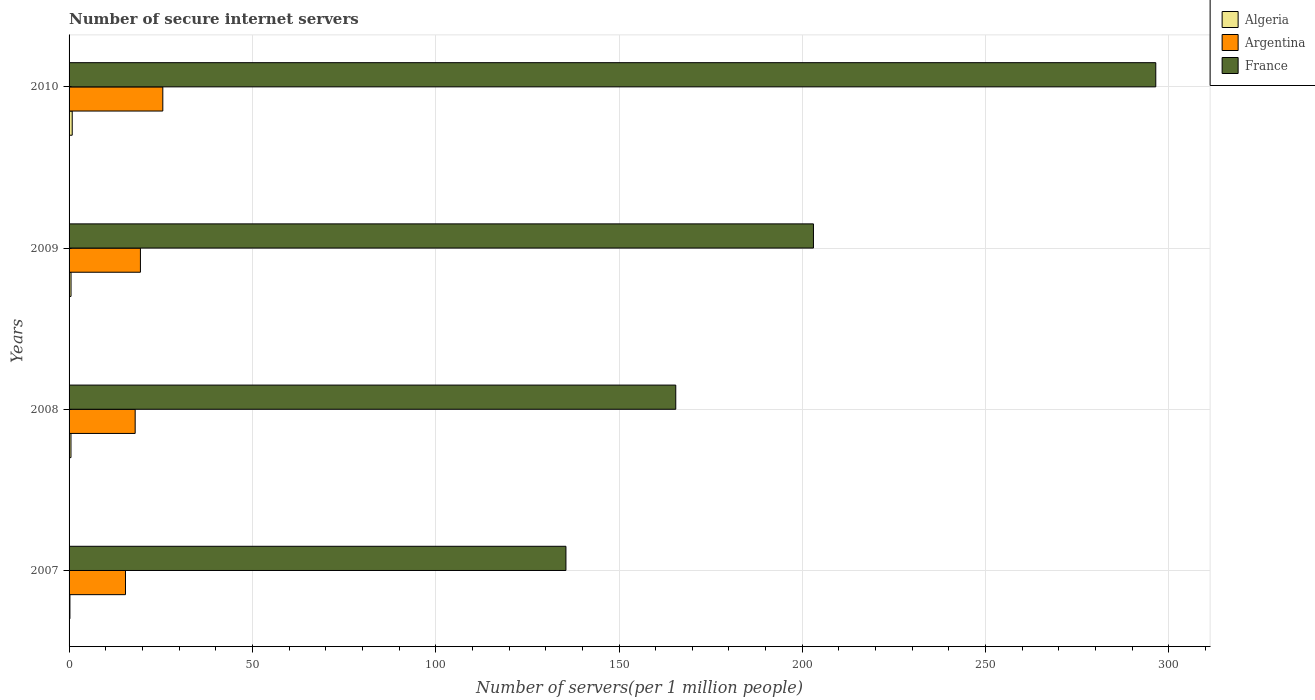How many different coloured bars are there?
Your answer should be compact. 3. How many groups of bars are there?
Ensure brevity in your answer.  4. Are the number of bars per tick equal to the number of legend labels?
Ensure brevity in your answer.  Yes. How many bars are there on the 4th tick from the top?
Make the answer very short. 3. How many bars are there on the 3rd tick from the bottom?
Make the answer very short. 3. What is the number of secure internet servers in Algeria in 2010?
Ensure brevity in your answer.  0.86. Across all years, what is the maximum number of secure internet servers in Algeria?
Give a very brief answer. 0.86. Across all years, what is the minimum number of secure internet servers in France?
Make the answer very short. 135.53. In which year was the number of secure internet servers in Argentina maximum?
Your answer should be compact. 2010. In which year was the number of secure internet servers in Algeria minimum?
Provide a succinct answer. 2007. What is the total number of secure internet servers in Algeria in the graph?
Provide a short and direct response. 2.15. What is the difference between the number of secure internet servers in Algeria in 2007 and that in 2009?
Provide a short and direct response. -0.3. What is the difference between the number of secure internet servers in Argentina in 2010 and the number of secure internet servers in Algeria in 2007?
Provide a succinct answer. 25.33. What is the average number of secure internet servers in Algeria per year?
Your response must be concise. 0.54. In the year 2009, what is the difference between the number of secure internet servers in Argentina and number of secure internet servers in France?
Ensure brevity in your answer.  -183.58. In how many years, is the number of secure internet servers in France greater than 30 ?
Make the answer very short. 4. What is the ratio of the number of secure internet servers in Argentina in 2007 to that in 2008?
Ensure brevity in your answer.  0.85. Is the number of secure internet servers in Algeria in 2008 less than that in 2009?
Make the answer very short. Yes. What is the difference between the highest and the second highest number of secure internet servers in Algeria?
Provide a short and direct response. 0.32. What is the difference between the highest and the lowest number of secure internet servers in Argentina?
Offer a very short reply. 10.18. What does the 1st bar from the bottom in 2008 represents?
Offer a terse response. Algeria. Is it the case that in every year, the sum of the number of secure internet servers in Algeria and number of secure internet servers in France is greater than the number of secure internet servers in Argentina?
Your answer should be very brief. Yes. How many years are there in the graph?
Your answer should be very brief. 4. What is the difference between two consecutive major ticks on the X-axis?
Give a very brief answer. 50. Does the graph contain any zero values?
Ensure brevity in your answer.  No. Does the graph contain grids?
Your response must be concise. Yes. Where does the legend appear in the graph?
Provide a short and direct response. Top right. How many legend labels are there?
Provide a succinct answer. 3. What is the title of the graph?
Your answer should be compact. Number of secure internet servers. What is the label or title of the X-axis?
Give a very brief answer. Number of servers(per 1 million people). What is the label or title of the Y-axis?
Offer a very short reply. Years. What is the Number of servers(per 1 million people) of Algeria in 2007?
Provide a short and direct response. 0.23. What is the Number of servers(per 1 million people) of Argentina in 2007?
Offer a terse response. 15.39. What is the Number of servers(per 1 million people) of France in 2007?
Provide a succinct answer. 135.53. What is the Number of servers(per 1 million people) in Algeria in 2008?
Offer a terse response. 0.52. What is the Number of servers(per 1 million people) of Argentina in 2008?
Offer a very short reply. 18.03. What is the Number of servers(per 1 million people) in France in 2008?
Give a very brief answer. 165.48. What is the Number of servers(per 1 million people) in Algeria in 2009?
Make the answer very short. 0.54. What is the Number of servers(per 1 million people) in Argentina in 2009?
Keep it short and to the point. 19.46. What is the Number of servers(per 1 million people) of France in 2009?
Provide a succinct answer. 203.04. What is the Number of servers(per 1 million people) in Algeria in 2010?
Ensure brevity in your answer.  0.86. What is the Number of servers(per 1 million people) of Argentina in 2010?
Keep it short and to the point. 25.57. What is the Number of servers(per 1 million people) in France in 2010?
Offer a very short reply. 296.41. Across all years, what is the maximum Number of servers(per 1 million people) of Algeria?
Your answer should be very brief. 0.86. Across all years, what is the maximum Number of servers(per 1 million people) in Argentina?
Offer a very short reply. 25.57. Across all years, what is the maximum Number of servers(per 1 million people) in France?
Provide a succinct answer. 296.41. Across all years, what is the minimum Number of servers(per 1 million people) of Algeria?
Make the answer very short. 0.23. Across all years, what is the minimum Number of servers(per 1 million people) of Argentina?
Provide a short and direct response. 15.39. Across all years, what is the minimum Number of servers(per 1 million people) of France?
Keep it short and to the point. 135.53. What is the total Number of servers(per 1 million people) of Algeria in the graph?
Offer a very short reply. 2.15. What is the total Number of servers(per 1 million people) of Argentina in the graph?
Offer a terse response. 78.44. What is the total Number of servers(per 1 million people) in France in the graph?
Your response must be concise. 800.46. What is the difference between the Number of servers(per 1 million people) in Algeria in 2007 and that in 2008?
Offer a terse response. -0.28. What is the difference between the Number of servers(per 1 million people) in Argentina in 2007 and that in 2008?
Provide a short and direct response. -2.64. What is the difference between the Number of servers(per 1 million people) of France in 2007 and that in 2008?
Your answer should be very brief. -29.96. What is the difference between the Number of servers(per 1 million people) of Algeria in 2007 and that in 2009?
Your answer should be compact. -0.3. What is the difference between the Number of servers(per 1 million people) of Argentina in 2007 and that in 2009?
Your answer should be very brief. -4.07. What is the difference between the Number of servers(per 1 million people) of France in 2007 and that in 2009?
Make the answer very short. -67.51. What is the difference between the Number of servers(per 1 million people) of Algeria in 2007 and that in 2010?
Provide a succinct answer. -0.63. What is the difference between the Number of servers(per 1 million people) in Argentina in 2007 and that in 2010?
Your answer should be very brief. -10.18. What is the difference between the Number of servers(per 1 million people) of France in 2007 and that in 2010?
Your answer should be compact. -160.88. What is the difference between the Number of servers(per 1 million people) in Algeria in 2008 and that in 2009?
Your response must be concise. -0.02. What is the difference between the Number of servers(per 1 million people) of Argentina in 2008 and that in 2009?
Offer a very short reply. -1.43. What is the difference between the Number of servers(per 1 million people) of France in 2008 and that in 2009?
Make the answer very short. -37.55. What is the difference between the Number of servers(per 1 million people) of Algeria in 2008 and that in 2010?
Provide a succinct answer. -0.34. What is the difference between the Number of servers(per 1 million people) of Argentina in 2008 and that in 2010?
Provide a short and direct response. -7.54. What is the difference between the Number of servers(per 1 million people) of France in 2008 and that in 2010?
Your answer should be compact. -130.93. What is the difference between the Number of servers(per 1 million people) of Algeria in 2009 and that in 2010?
Give a very brief answer. -0.32. What is the difference between the Number of servers(per 1 million people) in Argentina in 2009 and that in 2010?
Your response must be concise. -6.11. What is the difference between the Number of servers(per 1 million people) in France in 2009 and that in 2010?
Make the answer very short. -93.37. What is the difference between the Number of servers(per 1 million people) in Algeria in 2007 and the Number of servers(per 1 million people) in Argentina in 2008?
Give a very brief answer. -17.79. What is the difference between the Number of servers(per 1 million people) in Algeria in 2007 and the Number of servers(per 1 million people) in France in 2008?
Your response must be concise. -165.25. What is the difference between the Number of servers(per 1 million people) in Argentina in 2007 and the Number of servers(per 1 million people) in France in 2008?
Provide a short and direct response. -150.1. What is the difference between the Number of servers(per 1 million people) of Algeria in 2007 and the Number of servers(per 1 million people) of Argentina in 2009?
Ensure brevity in your answer.  -19.23. What is the difference between the Number of servers(per 1 million people) of Algeria in 2007 and the Number of servers(per 1 million people) of France in 2009?
Your response must be concise. -202.8. What is the difference between the Number of servers(per 1 million people) in Argentina in 2007 and the Number of servers(per 1 million people) in France in 2009?
Make the answer very short. -187.65. What is the difference between the Number of servers(per 1 million people) in Algeria in 2007 and the Number of servers(per 1 million people) in Argentina in 2010?
Your response must be concise. -25.33. What is the difference between the Number of servers(per 1 million people) of Algeria in 2007 and the Number of servers(per 1 million people) of France in 2010?
Your response must be concise. -296.18. What is the difference between the Number of servers(per 1 million people) in Argentina in 2007 and the Number of servers(per 1 million people) in France in 2010?
Ensure brevity in your answer.  -281.03. What is the difference between the Number of servers(per 1 million people) in Algeria in 2008 and the Number of servers(per 1 million people) in Argentina in 2009?
Offer a terse response. -18.94. What is the difference between the Number of servers(per 1 million people) of Algeria in 2008 and the Number of servers(per 1 million people) of France in 2009?
Provide a succinct answer. -202.52. What is the difference between the Number of servers(per 1 million people) of Argentina in 2008 and the Number of servers(per 1 million people) of France in 2009?
Ensure brevity in your answer.  -185.01. What is the difference between the Number of servers(per 1 million people) of Algeria in 2008 and the Number of servers(per 1 million people) of Argentina in 2010?
Give a very brief answer. -25.05. What is the difference between the Number of servers(per 1 million people) of Algeria in 2008 and the Number of servers(per 1 million people) of France in 2010?
Keep it short and to the point. -295.9. What is the difference between the Number of servers(per 1 million people) in Argentina in 2008 and the Number of servers(per 1 million people) in France in 2010?
Ensure brevity in your answer.  -278.39. What is the difference between the Number of servers(per 1 million people) in Algeria in 2009 and the Number of servers(per 1 million people) in Argentina in 2010?
Make the answer very short. -25.03. What is the difference between the Number of servers(per 1 million people) in Algeria in 2009 and the Number of servers(per 1 million people) in France in 2010?
Offer a very short reply. -295.88. What is the difference between the Number of servers(per 1 million people) in Argentina in 2009 and the Number of servers(per 1 million people) in France in 2010?
Give a very brief answer. -276.95. What is the average Number of servers(per 1 million people) of Algeria per year?
Offer a terse response. 0.54. What is the average Number of servers(per 1 million people) of Argentina per year?
Give a very brief answer. 19.61. What is the average Number of servers(per 1 million people) in France per year?
Make the answer very short. 200.12. In the year 2007, what is the difference between the Number of servers(per 1 million people) in Algeria and Number of servers(per 1 million people) in Argentina?
Provide a short and direct response. -15.15. In the year 2007, what is the difference between the Number of servers(per 1 million people) of Algeria and Number of servers(per 1 million people) of France?
Your answer should be compact. -135.29. In the year 2007, what is the difference between the Number of servers(per 1 million people) of Argentina and Number of servers(per 1 million people) of France?
Make the answer very short. -120.14. In the year 2008, what is the difference between the Number of servers(per 1 million people) of Algeria and Number of servers(per 1 million people) of Argentina?
Your answer should be compact. -17.51. In the year 2008, what is the difference between the Number of servers(per 1 million people) of Algeria and Number of servers(per 1 million people) of France?
Your answer should be very brief. -164.97. In the year 2008, what is the difference between the Number of servers(per 1 million people) in Argentina and Number of servers(per 1 million people) in France?
Give a very brief answer. -147.46. In the year 2009, what is the difference between the Number of servers(per 1 million people) in Algeria and Number of servers(per 1 million people) in Argentina?
Your answer should be compact. -18.92. In the year 2009, what is the difference between the Number of servers(per 1 million people) of Algeria and Number of servers(per 1 million people) of France?
Ensure brevity in your answer.  -202.5. In the year 2009, what is the difference between the Number of servers(per 1 million people) of Argentina and Number of servers(per 1 million people) of France?
Provide a short and direct response. -183.58. In the year 2010, what is the difference between the Number of servers(per 1 million people) in Algeria and Number of servers(per 1 million people) in Argentina?
Your response must be concise. -24.71. In the year 2010, what is the difference between the Number of servers(per 1 million people) in Algeria and Number of servers(per 1 million people) in France?
Your answer should be compact. -295.55. In the year 2010, what is the difference between the Number of servers(per 1 million people) in Argentina and Number of servers(per 1 million people) in France?
Your answer should be compact. -270.84. What is the ratio of the Number of servers(per 1 million people) of Algeria in 2007 to that in 2008?
Offer a very short reply. 0.45. What is the ratio of the Number of servers(per 1 million people) in Argentina in 2007 to that in 2008?
Your answer should be very brief. 0.85. What is the ratio of the Number of servers(per 1 million people) in France in 2007 to that in 2008?
Your answer should be very brief. 0.82. What is the ratio of the Number of servers(per 1 million people) of Algeria in 2007 to that in 2009?
Your response must be concise. 0.44. What is the ratio of the Number of servers(per 1 million people) in Argentina in 2007 to that in 2009?
Offer a terse response. 0.79. What is the ratio of the Number of servers(per 1 million people) of France in 2007 to that in 2009?
Your answer should be very brief. 0.67. What is the ratio of the Number of servers(per 1 million people) in Algeria in 2007 to that in 2010?
Offer a very short reply. 0.27. What is the ratio of the Number of servers(per 1 million people) in Argentina in 2007 to that in 2010?
Your answer should be compact. 0.6. What is the ratio of the Number of servers(per 1 million people) of France in 2007 to that in 2010?
Offer a terse response. 0.46. What is the ratio of the Number of servers(per 1 million people) in Algeria in 2008 to that in 2009?
Ensure brevity in your answer.  0.96. What is the ratio of the Number of servers(per 1 million people) of Argentina in 2008 to that in 2009?
Offer a very short reply. 0.93. What is the ratio of the Number of servers(per 1 million people) of France in 2008 to that in 2009?
Provide a short and direct response. 0.81. What is the ratio of the Number of servers(per 1 million people) of Algeria in 2008 to that in 2010?
Your response must be concise. 0.6. What is the ratio of the Number of servers(per 1 million people) in Argentina in 2008 to that in 2010?
Offer a terse response. 0.71. What is the ratio of the Number of servers(per 1 million people) in France in 2008 to that in 2010?
Provide a succinct answer. 0.56. What is the ratio of the Number of servers(per 1 million people) of Algeria in 2009 to that in 2010?
Ensure brevity in your answer.  0.62. What is the ratio of the Number of servers(per 1 million people) of Argentina in 2009 to that in 2010?
Make the answer very short. 0.76. What is the ratio of the Number of servers(per 1 million people) of France in 2009 to that in 2010?
Provide a succinct answer. 0.69. What is the difference between the highest and the second highest Number of servers(per 1 million people) in Algeria?
Offer a very short reply. 0.32. What is the difference between the highest and the second highest Number of servers(per 1 million people) in Argentina?
Provide a succinct answer. 6.11. What is the difference between the highest and the second highest Number of servers(per 1 million people) of France?
Ensure brevity in your answer.  93.37. What is the difference between the highest and the lowest Number of servers(per 1 million people) in Algeria?
Provide a short and direct response. 0.63. What is the difference between the highest and the lowest Number of servers(per 1 million people) in Argentina?
Offer a very short reply. 10.18. What is the difference between the highest and the lowest Number of servers(per 1 million people) of France?
Your answer should be very brief. 160.88. 